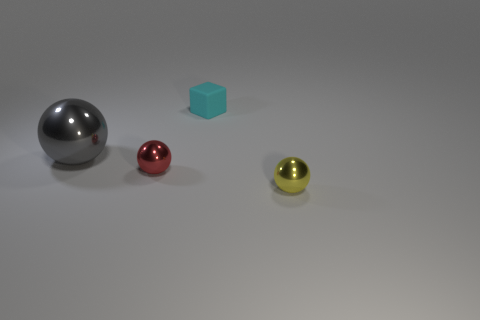Add 4 big purple matte things. How many objects exist? 8 Subtract all balls. How many objects are left? 1 Add 1 large things. How many large things are left? 2 Add 4 large brown metallic cubes. How many large brown metallic cubes exist? 4 Subtract 0 brown balls. How many objects are left? 4 Subtract all cyan matte objects. Subtract all large gray shiny objects. How many objects are left? 2 